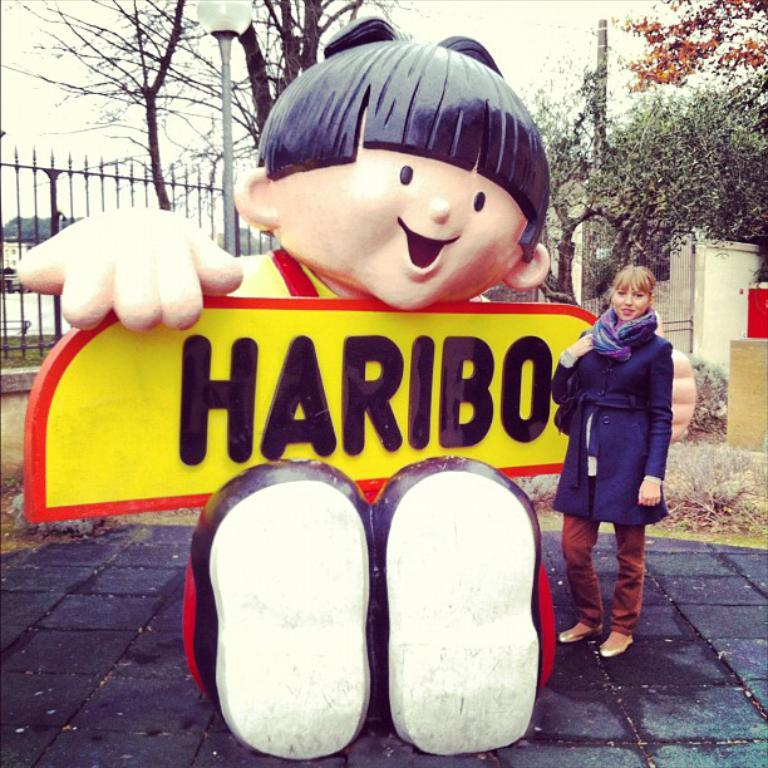Who is present in the image? There is a woman in the image. What is the woman wearing around her neck? The woman is wearing a stole. What else is the woman wearing? The woman is wearing a coat. What type of artwork can be seen in the image? There is a sculpture in the image. What architectural feature is present in the image? There is a fence in the image. What are the vertical structures in the image? There are poles in the image. What type of vegetation is visible in the image? There are trees in the image. What page is the woman turning in the image? There is no indication of a book or page in the image; it features a woman wearing a stole and coat, along with other elements like a sculpture, fence, poles, and trees. 